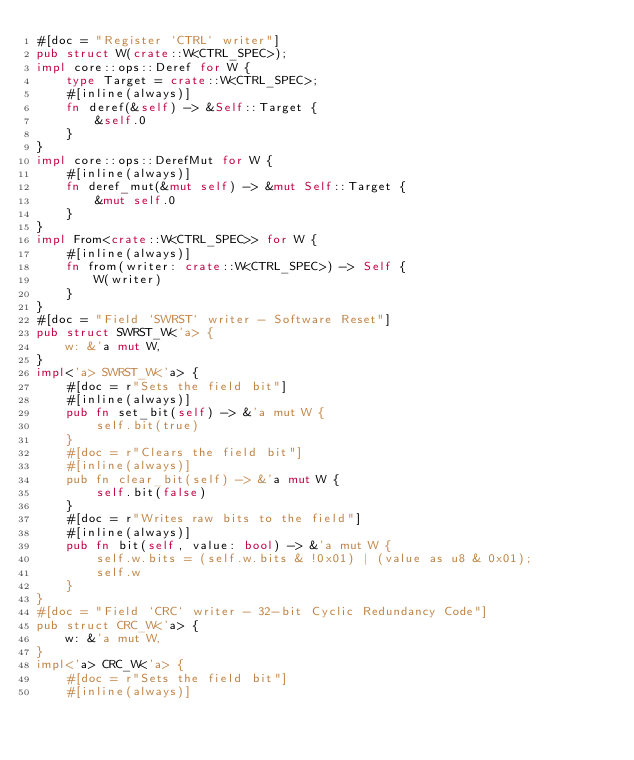<code> <loc_0><loc_0><loc_500><loc_500><_Rust_>#[doc = "Register `CTRL` writer"]
pub struct W(crate::W<CTRL_SPEC>);
impl core::ops::Deref for W {
    type Target = crate::W<CTRL_SPEC>;
    #[inline(always)]
    fn deref(&self) -> &Self::Target {
        &self.0
    }
}
impl core::ops::DerefMut for W {
    #[inline(always)]
    fn deref_mut(&mut self) -> &mut Self::Target {
        &mut self.0
    }
}
impl From<crate::W<CTRL_SPEC>> for W {
    #[inline(always)]
    fn from(writer: crate::W<CTRL_SPEC>) -> Self {
        W(writer)
    }
}
#[doc = "Field `SWRST` writer - Software Reset"]
pub struct SWRST_W<'a> {
    w: &'a mut W,
}
impl<'a> SWRST_W<'a> {
    #[doc = r"Sets the field bit"]
    #[inline(always)]
    pub fn set_bit(self) -> &'a mut W {
        self.bit(true)
    }
    #[doc = r"Clears the field bit"]
    #[inline(always)]
    pub fn clear_bit(self) -> &'a mut W {
        self.bit(false)
    }
    #[doc = r"Writes raw bits to the field"]
    #[inline(always)]
    pub fn bit(self, value: bool) -> &'a mut W {
        self.w.bits = (self.w.bits & !0x01) | (value as u8 & 0x01);
        self.w
    }
}
#[doc = "Field `CRC` writer - 32-bit Cyclic Redundancy Code"]
pub struct CRC_W<'a> {
    w: &'a mut W,
}
impl<'a> CRC_W<'a> {
    #[doc = r"Sets the field bit"]
    #[inline(always)]</code> 